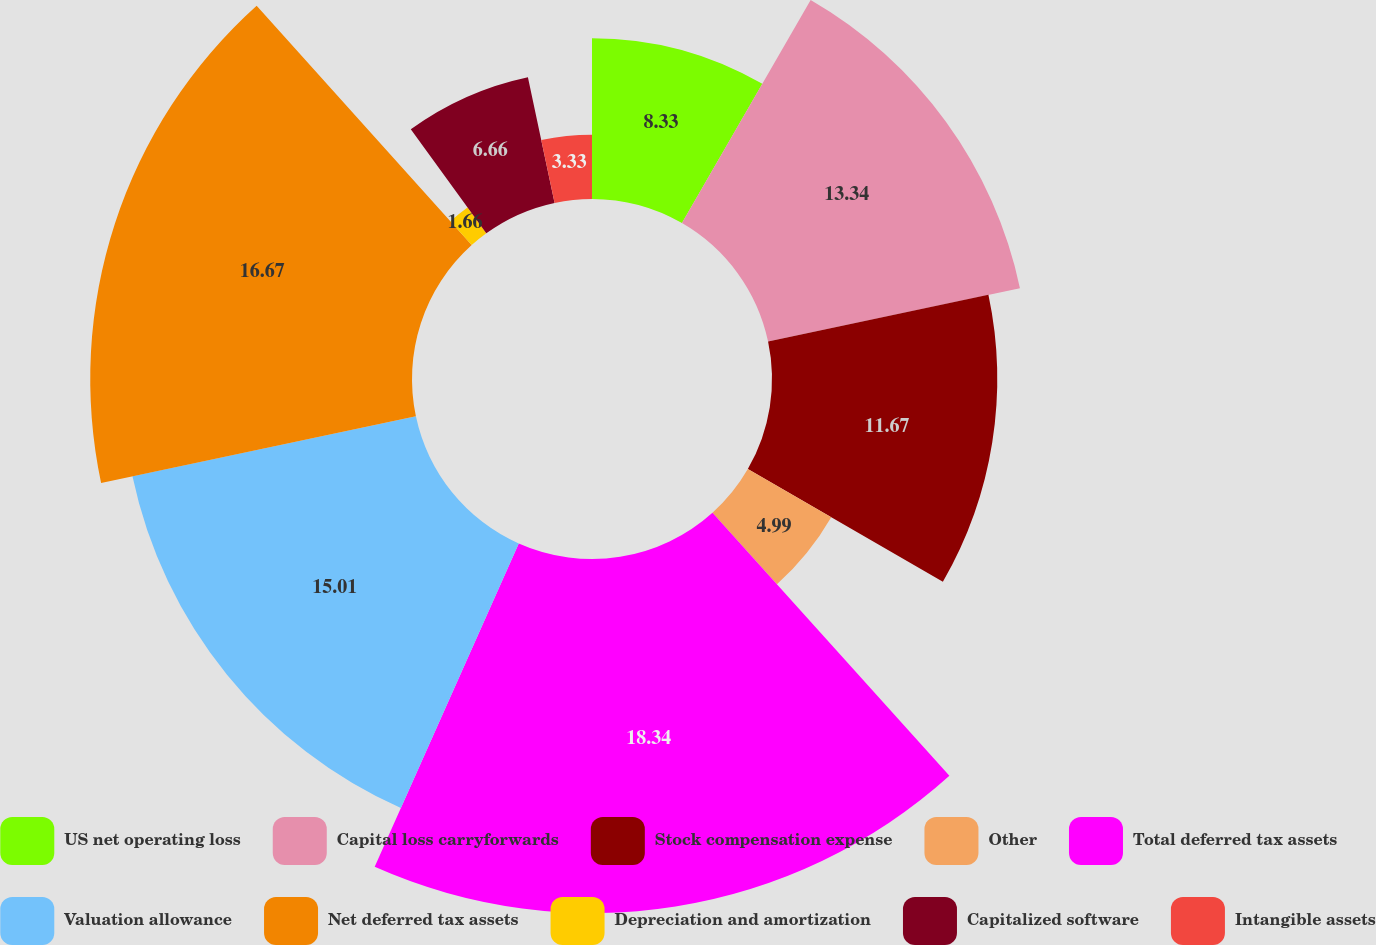Convert chart. <chart><loc_0><loc_0><loc_500><loc_500><pie_chart><fcel>US net operating loss<fcel>Capital loss carryforwards<fcel>Stock compensation expense<fcel>Other<fcel>Total deferred tax assets<fcel>Valuation allowance<fcel>Net deferred tax assets<fcel>Depreciation and amortization<fcel>Capitalized software<fcel>Intangible assets<nl><fcel>8.33%<fcel>13.34%<fcel>11.67%<fcel>4.99%<fcel>18.34%<fcel>15.01%<fcel>16.67%<fcel>1.66%<fcel>6.66%<fcel>3.33%<nl></chart> 